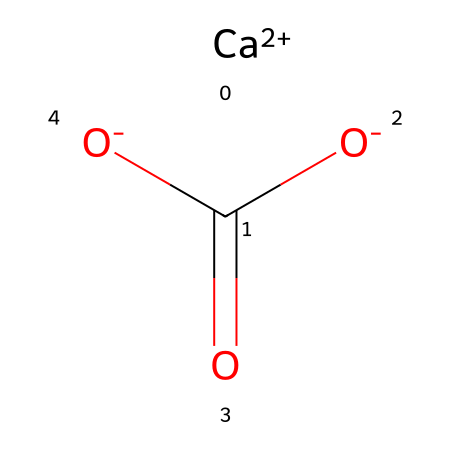What is the formula of the antacid compound shown? The SMILES representation indicates the elements and their quantities: one calcium atom (Ca), one carbon atom (C), and three oxygen atoms (O), forming the formula CaCO3.
Answer: CaCO3 How many oxygen atoms are in this compound? Analyzing the SMILES representation, there are three oxygen atoms (O) present in the formula.
Answer: 3 What is the charge of the calcium ion in this compound? The SMILES notation shows [Ca+2], indicating that the calcium ion has a +2 charge.
Answer: +2 What type of compound is calcium carbonate in the context of antacids? Calcium carbonate is classified as a base, which is used to neutralize stomach acid.
Answer: base What is the oxidation state of carbon in this compound? In the compound represented, carbon is bonded to three oxygen atoms, and since it's using one double bond and two single bonds in a carbonate ion, it has an oxidation state of +4.
Answer: +4 How many total atoms are present in the compound? Counting the individual atoms from the formula CaCO3 gives one calcium ion, one carbon atom, and three oxygen atoms, totaling five atoms.
Answer: 5 What type of reaction is calcium carbonate commonly involved in? Calcium carbonate primarily participates in neutralization reactions, where it reacts with acids to form water and carbon dioxide.
Answer: neutralization 